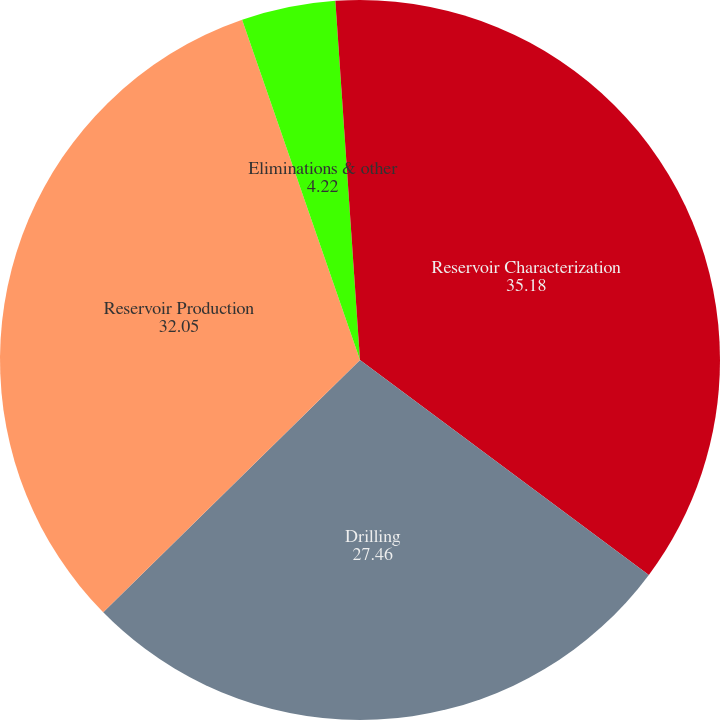Convert chart to OTSL. <chart><loc_0><loc_0><loc_500><loc_500><pie_chart><fcel>Reservoir Characterization<fcel>Drilling<fcel>Reservoir Production<fcel>Eliminations & other<fcel>Distribution<nl><fcel>35.18%<fcel>27.46%<fcel>32.05%<fcel>4.22%<fcel>1.09%<nl></chart> 